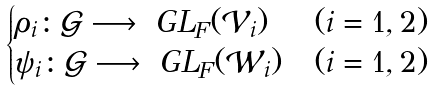Convert formula to latex. <formula><loc_0><loc_0><loc_500><loc_500>\begin{cases} \rho _ { i } \colon \mathcal { G } \longrightarrow \ G L _ { F } ( \mathcal { V } _ { i } ) & ( i = 1 , 2 ) \\ \psi _ { i } \colon \mathcal { G } \longrightarrow \ G L _ { F } ( \mathcal { W } _ { i } ) & ( i = 1 , 2 ) \\ \end{cases}</formula> 